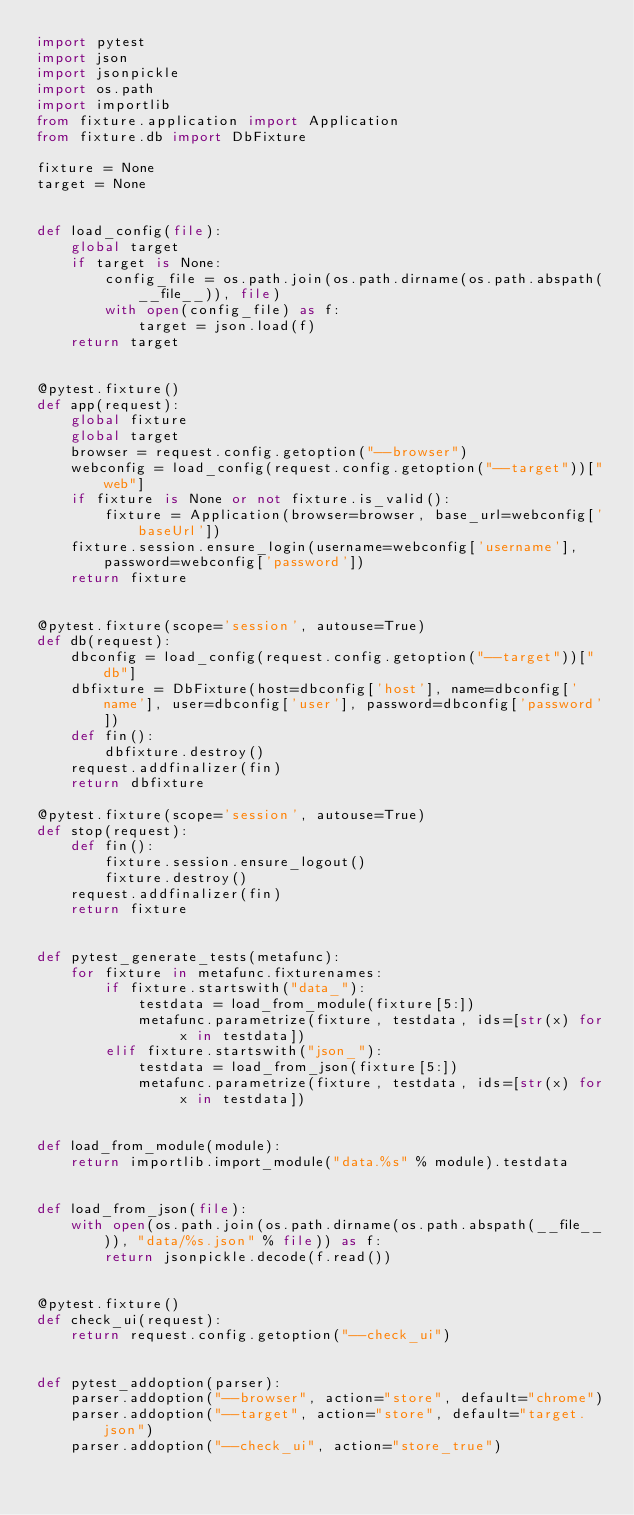Convert code to text. <code><loc_0><loc_0><loc_500><loc_500><_Python_>import pytest
import json
import jsonpickle
import os.path
import importlib
from fixture.application import Application
from fixture.db import DbFixture

fixture = None
target = None


def load_config(file):
    global target
    if target is None:
        config_file = os.path.join(os.path.dirname(os.path.abspath(__file__)), file)
        with open(config_file) as f:
            target = json.load(f)
    return target


@pytest.fixture()
def app(request):
    global fixture
    global target
    browser = request.config.getoption("--browser")
    webconfig = load_config(request.config.getoption("--target"))["web"]
    if fixture is None or not fixture.is_valid():
        fixture = Application(browser=browser, base_url=webconfig['baseUrl'])
    fixture.session.ensure_login(username=webconfig['username'], password=webconfig['password'])
    return fixture


@pytest.fixture(scope='session', autouse=True)
def db(request):
    dbconfig = load_config(request.config.getoption("--target"))["db"]
    dbfixture = DbFixture(host=dbconfig['host'], name=dbconfig['name'], user=dbconfig['user'], password=dbconfig['password'])
    def fin():
        dbfixture.destroy()
    request.addfinalizer(fin)
    return dbfixture

@pytest.fixture(scope='session', autouse=True)
def stop(request):
    def fin():
        fixture.session.ensure_logout()
        fixture.destroy()
    request.addfinalizer(fin)
    return fixture


def pytest_generate_tests(metafunc):
    for fixture in metafunc.fixturenames:
        if fixture.startswith("data_"):
            testdata = load_from_module(fixture[5:])
            metafunc.parametrize(fixture, testdata, ids=[str(x) for x in testdata])
        elif fixture.startswith("json_"):
            testdata = load_from_json(fixture[5:])
            metafunc.parametrize(fixture, testdata, ids=[str(x) for x in testdata])


def load_from_module(module):
    return importlib.import_module("data.%s" % module).testdata


def load_from_json(file):
    with open(os.path.join(os.path.dirname(os.path.abspath(__file__)), "data/%s.json" % file)) as f:
        return jsonpickle.decode(f.read())


@pytest.fixture()
def check_ui(request):
    return request.config.getoption("--check_ui")


def pytest_addoption(parser):
    parser.addoption("--browser", action="store", default="chrome")
    parser.addoption("--target", action="store", default="target.json")
    parser.addoption("--check_ui", action="store_true")
</code> 